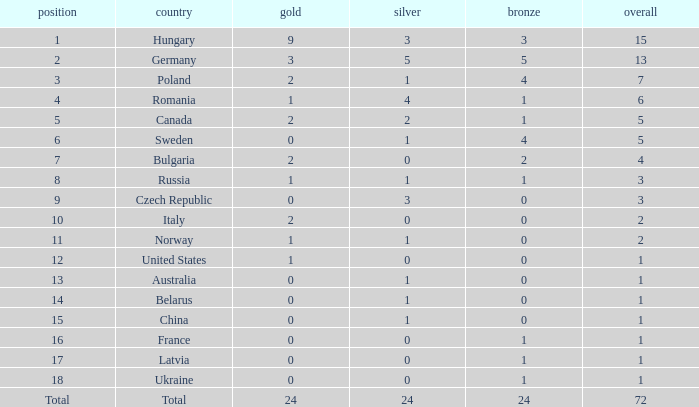What average total has 0 as the gold, with 6 as the rank? 5.0. 